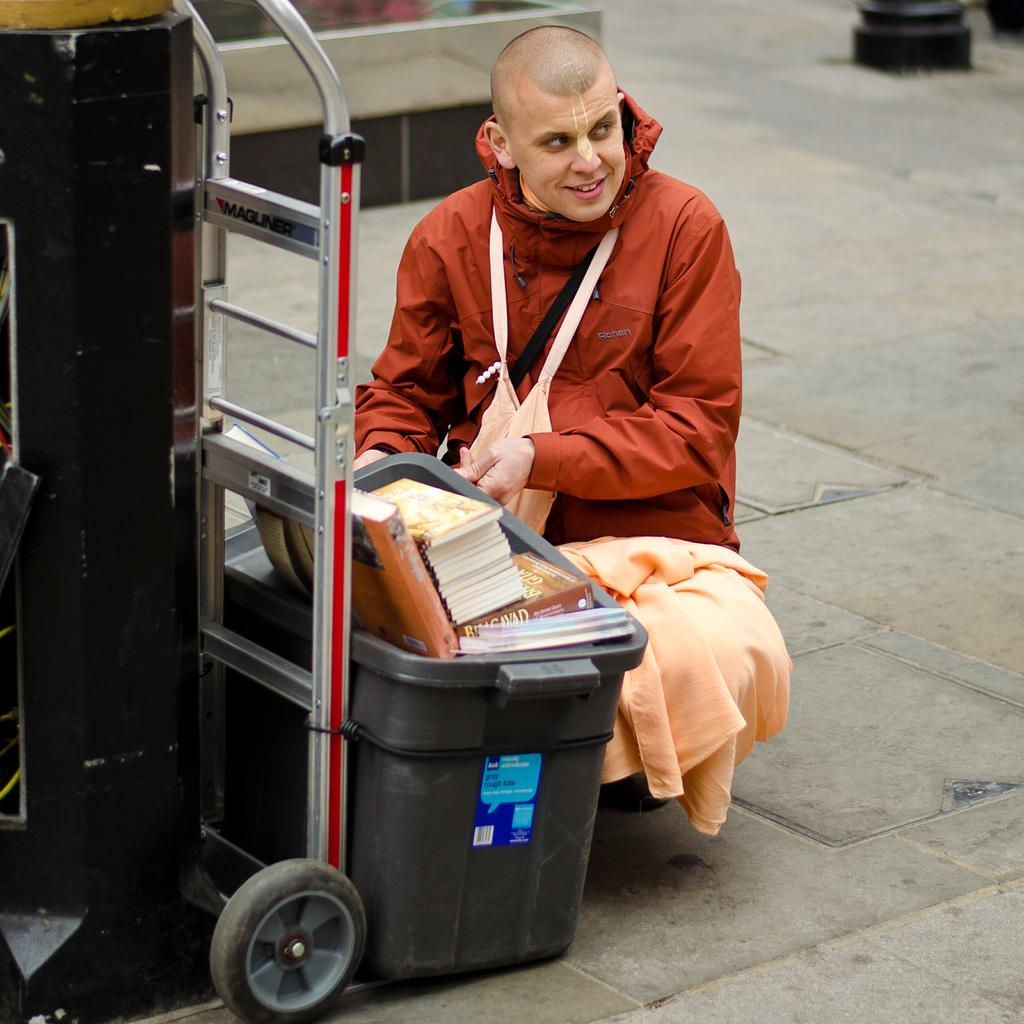Who or what is present in the image? There is a person in the image. What is the person wearing? The person is wearing a brown dress. What objects are near the person? There are books in a basket in front of the person. What other item can be seen in the image? There is a trolley visible in the image. What type of corn is being harvested by the person in the image? There is no corn or harvesting activity present in the image; it features a person wearing a brown dress with books in a basket and a trolley visible. 